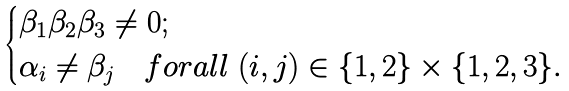<formula> <loc_0><loc_0><loc_500><loc_500>\begin{cases} \beta _ { 1 } \beta _ { 2 } \beta _ { 3 } \neq 0 ; \\ \alpha _ { i } \neq \beta _ { j } \ \ \ f o r a l l \ ( i , j ) \in \{ 1 , 2 \} \times \{ 1 , 2 , 3 \} . \end{cases}</formula> 